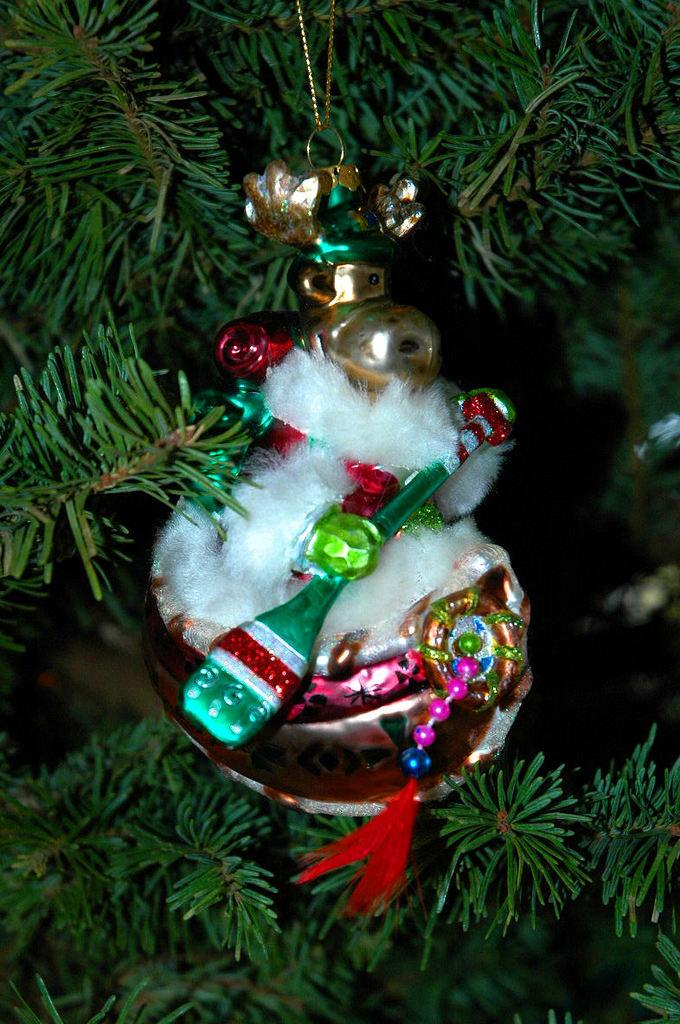What is the main subject in the middle of the image? There is an object in the middle of the image. What can be seen in the background of the image? There are plants in the background of the image. What is the color of the background in the image? The background of the image has a black color. How many people are jumping in fear in the image? There are no people present in the image, and therefore no one is jumping in fear. 